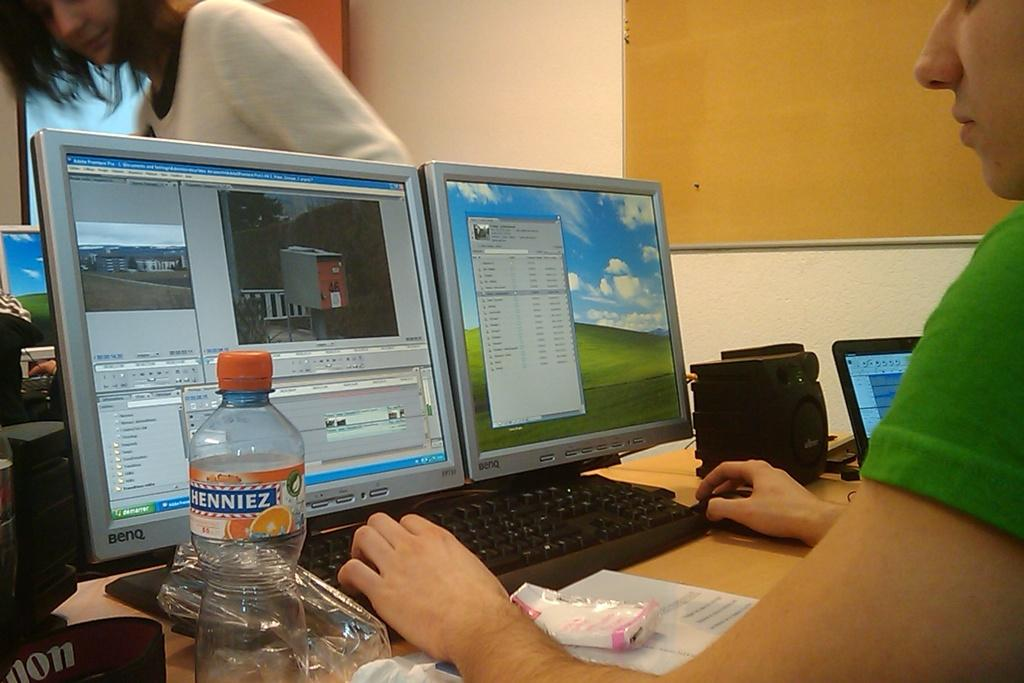<image>
Provide a brief description of the given image. Windows 95 can be used with BenQ brand monitors. 